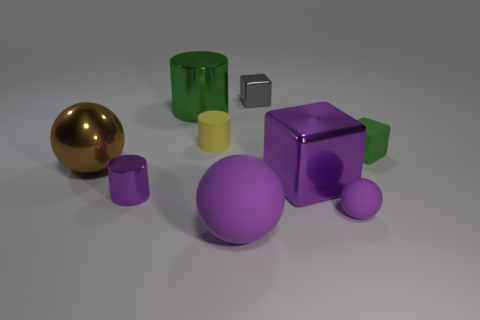Add 1 green cubes. How many objects exist? 10 Subtract all blocks. How many objects are left? 6 Add 6 tiny yellow rubber cylinders. How many tiny yellow rubber cylinders are left? 7 Add 8 gray metallic things. How many gray metallic things exist? 9 Subtract 1 yellow cylinders. How many objects are left? 8 Subtract all large shiny balls. Subtract all big green metallic things. How many objects are left? 7 